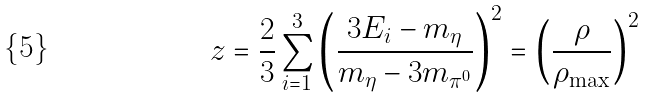<formula> <loc_0><loc_0><loc_500><loc_500>z = \frac { 2 } { 3 } \sum _ { i = 1 } ^ { 3 } \left ( \frac { 3 E _ { i } - m _ { \eta } } { m _ { \eta } - 3 m _ { \pi ^ { 0 } } } \right ) ^ { 2 } = \left ( \frac { \rho } { \rho _ { \max } } \right ) ^ { 2 }</formula> 